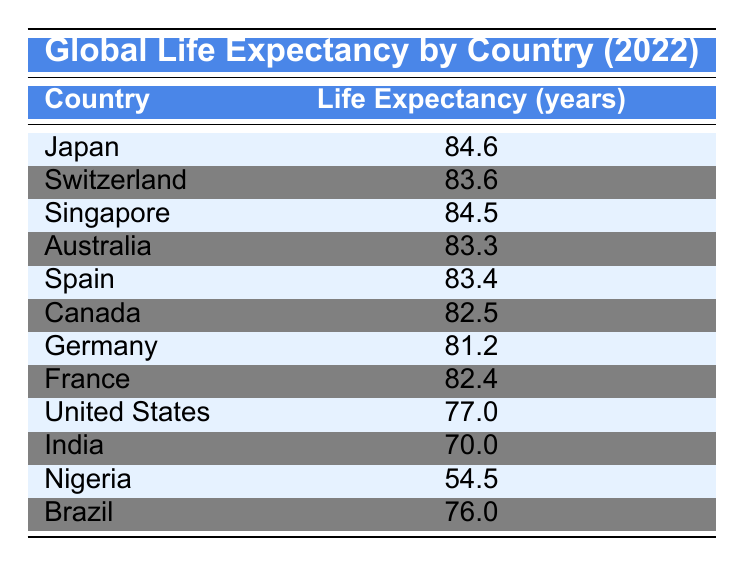What is the life expectancy in Japan? According to the table, Japan has a life expectancy of 84.6 years.
Answer: 84.6 Which country has the highest life expectancy? By scanning the table, Japan has the highest life expectancy at 84.6 years.
Answer: Japan What is the difference in life expectancy between Canada and Germany? Canada has a life expectancy of 82.5 years, while Germany's is 81.2 years. The difference is 82.5 - 81.2 = 1.3 years.
Answer: 1.3 Is the life expectancy in the United States higher than in Brazil? The life expectancy in the United States is 77.0 years, and in Brazil, it is 76.0 years. Since 77.0 is greater than 76.0, the statement is true.
Answer: Yes What is the average life expectancy of the countries listed? The sum of the life expectancies is (84.6 + 83.6 + 84.5 + 83.3 + 83.4 + 82.5 + 81.2 + 82.4 + 77.0 + 70.0 + 54.5 + 76.0) =  1,021.6 years. There are 12 countries, so the average is 1,021.6 / 12 = 85.13 years.
Answer: 85.13 Are there any countries with a life expectancy below 60 years? Nigeria has a life expectancy of 54.5 years, which is below 60 years. Thus, the statement is true.
Answer: Yes Which country has a life expectancy closest to 80 years? Examining the data, Germany (81.2) and France (82.4) are the closest, but Germany is slightly closer at 81.2 years.
Answer: Germany How many countries have a life expectancy above 80 years? Looking at the table, the countries with a life expectancy above 80 years are Japan, Switzerland, Singapore, Australia, Spain, Canada, and France, totaling 7 countries.
Answer: 7 If the life expectancy in India increased by 5 years, what would it be? Currently, India's life expectancy is 70.0 years. Adding 5 years would make it 70.0 + 5 = 75.0 years.
Answer: 75.0 